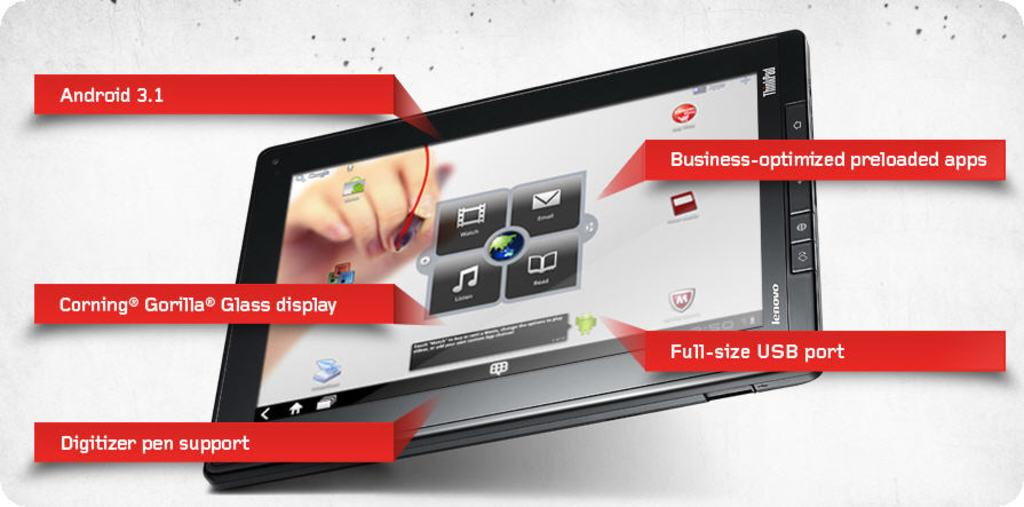<image>
Write a terse but informative summary of the picture. A tablet advertisement indicates that it has Andriod 3.1. 